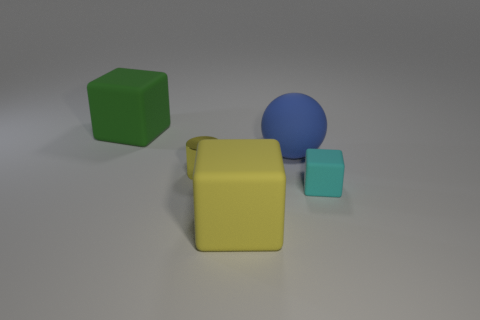What color is the big matte block that is in front of the big cube behind the yellow matte block?
Ensure brevity in your answer.  Yellow. Are there any tiny objects?
Your answer should be very brief. Yes. Do the metal thing and the large blue thing have the same shape?
Provide a succinct answer. No. What is the size of the rubber block that is the same color as the tiny shiny object?
Your response must be concise. Large. There is a yellow thing in front of the cylinder; what number of matte cubes are in front of it?
Offer a very short reply. 0. What number of matte objects are both in front of the small matte cube and behind the tiny yellow metallic cylinder?
Provide a short and direct response. 0. What number of things are large yellow shiny cylinders or cubes that are to the right of the big blue rubber ball?
Your response must be concise. 1. The yellow object that is the same material as the large sphere is what size?
Ensure brevity in your answer.  Large. What is the shape of the big thing that is to the left of the large matte block that is right of the green matte cube?
Offer a terse response. Cube. How many purple objects are rubber objects or tiny cubes?
Provide a succinct answer. 0. 